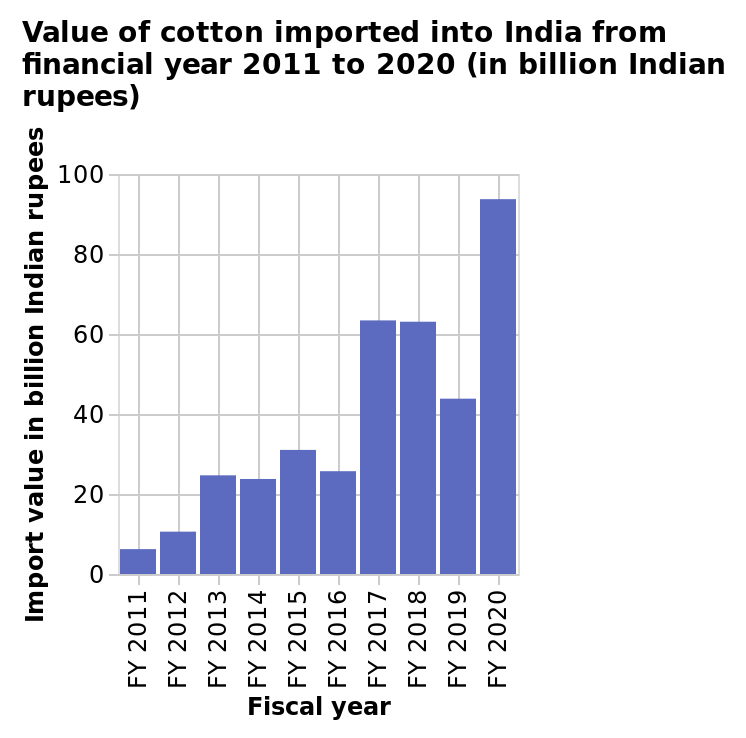<image>
Offer a thorough analysis of the image. The Bar chart appear to show an general uptrend which indicates that the value of imported cotton into India is increasing. Between the years 2011 - 2016 there is a gradual price increase. However Imported value jumps significantly betwen 2016-2017 approximately 158%. The imported value stays roughly the same between 2017 - 2018 at aroung 64 Billion Rupees, falling in 2019 to 42 Million. Imported value of Cotton the rises sharply close to 96 Billion Rupees in 2020. What is the range of values on the y-axis? The range of values on the y-axis is from 0 billion Indian rupees to 100 billion Indian rupees. How much did the imported value of cotton jump between 2016 and 2017?  The imported value of cotton jumped approximately 158% between 2016 and 2017. How much did the imported value of cotton rise in 2020? The imported value of cotton rose sharply to close to 96 Billion Rupees in 2020. 